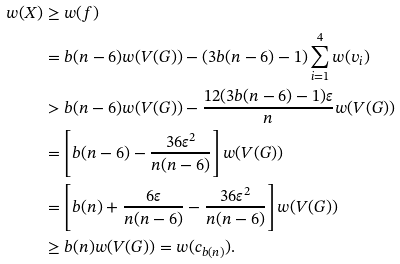Convert formula to latex. <formula><loc_0><loc_0><loc_500><loc_500>w ( X ) & \geq w ( f ) \\ & = b ( n - 6 ) w ( V ( G ) ) - ( 3 b ( n - 6 ) - 1 ) \sum _ { i = 1 } ^ { 4 } w ( v _ { i } ) \\ & > b ( n - 6 ) w ( V ( G ) ) - \frac { 1 2 ( 3 b ( n - 6 ) - 1 ) \varepsilon } { n } w ( V ( G ) ) \\ & = \left [ b ( n - 6 ) - \frac { 3 6 \varepsilon ^ { 2 } } { n ( n - 6 ) } \right ] w ( V ( G ) ) \\ & = \left [ b ( n ) + \frac { 6 \varepsilon } { n ( n - 6 ) } - \frac { 3 6 \varepsilon ^ { 2 } } { n ( n - 6 ) } \right ] w ( V ( G ) ) \\ & \geq b ( n ) w ( V ( G ) ) = w ( c _ { b ( n ) } ) .</formula> 